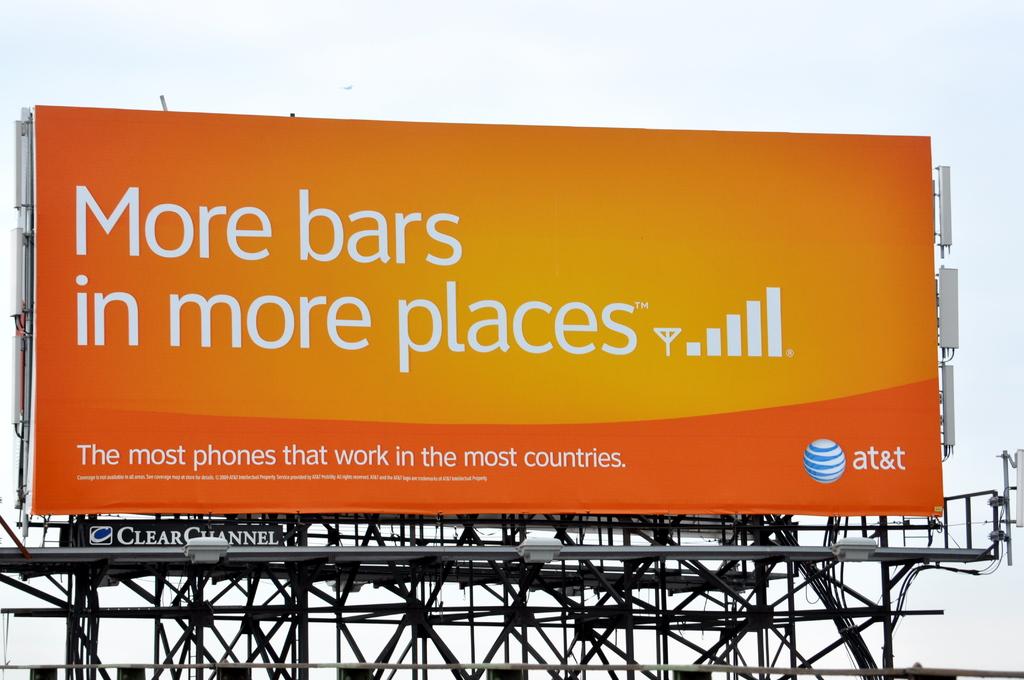What is the name of service provider on the billboard?
Ensure brevity in your answer.  At&t. 